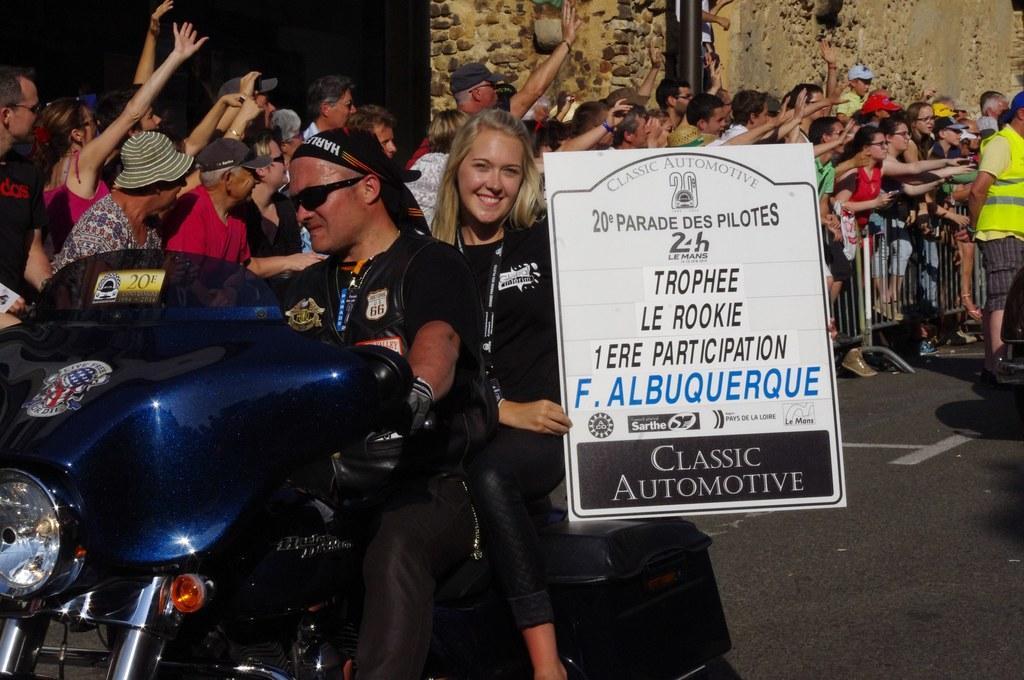Can you describe this image briefly? In this image i can see a man and a woman on a bike, a woman is holding a board and at the back ground i can see few people standing, a pole and a wall. 